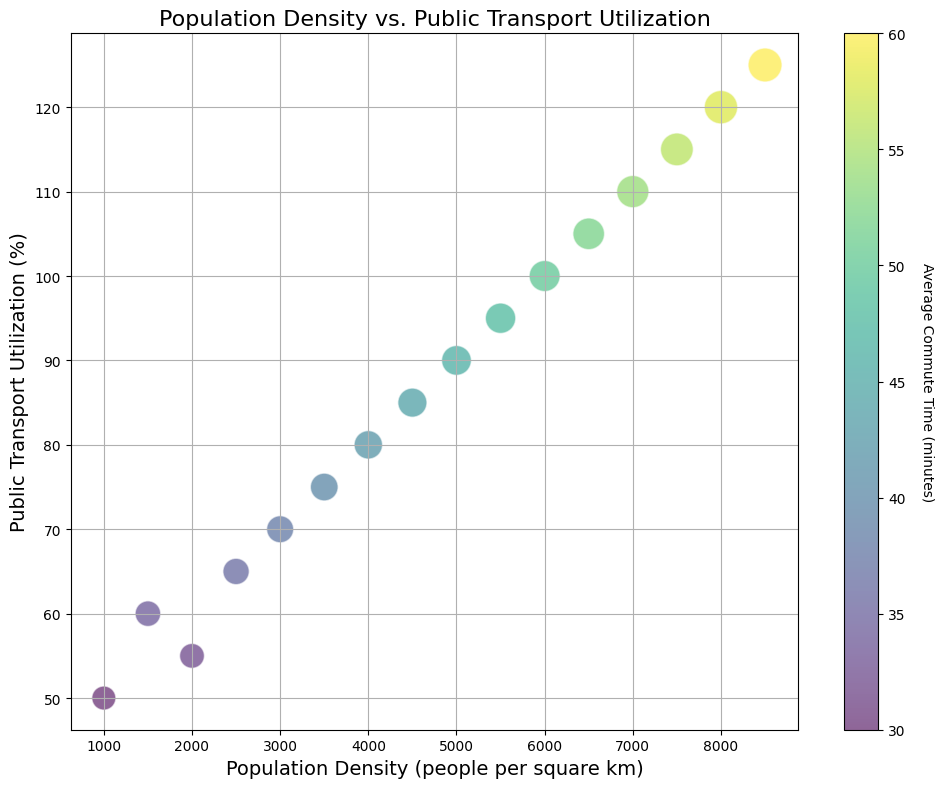What is the range of public transport utilization percentages? To find the range, subtract the smallest public transport utilization value (50%) from the largest utilization value (125%) observed in the chart.
Answer: 75% What is the average commute time for cities with a population density of 4000 people per square km? Identify the bubble size corresponding to the population density of 4000 people per square km, which is 42 minutes.
Answer: 42 minutes Is there a correlation between population density and public transport utilization? By visually examining the scatter plot, one notices that as population density increases, public transport utilization also tends to increase. This indicates a positive correlation.
Answer: Yes, there is a positive correlation Which city has the highest average commute time and what is its public transport utilization percentage? Identify the largest bubble in the plot, which represents the highest average commute time of 60 minutes. The corresponding public transport utilization percentage for this bubble is 125%.
Answer: 125% What is the change in average commute time as population density increases from 5000 to 7000 people per square km? Calculate the difference in average commute time between bubbles representing 7000 and 5000 population density: 54 - 46 = 8 minutes.
Answer: 8 minutes Among cities with population densities 2000 and 6500 people per square km, which one has a higher public transport utilization percentage and by how much? Public transport utilization for 2000 people per square km is 55%, while for 6500 people per square km, it is 105%. Calculate the difference: 105 - 55 = 50%.
Answer: 6500 people per square km by 50% How does average commute time visually affect the appearance of the bubbles in the chart? Larger average commute times result in bigger bubble sizes, indicating that as the average commute time increases, the bubble size also increases proportionally.
Answer: Larger bubble size What trend do you observe between the average commute time and public transport utilization? By observing the color gradient (viridis colormap), as the color of the bubbles shifts towards the higher end of the colormap (i.e., darker), average commute times and public transport utilization percentages both increase.
Answer: Both increase For cities with an average commute time of 50 minutes, what are the corresponding public transport utilization and population density? Locate the bubble colored appropriately for a 50-minute commute. The corresponding values from the data are population density of 6000 people per square km and public transport utilization of 100%.
Answer: 6000 people per square km, 100% Which cities have an average commute time of 38 minutes, and what are their population density and public transport utilization percentages? Identify the bubble sized according to a 38-minute commute time. The corresponding values are population density of 3000 people per square km and public transport utilization of 70%.
Answer: 3000 people per square km, 70% 